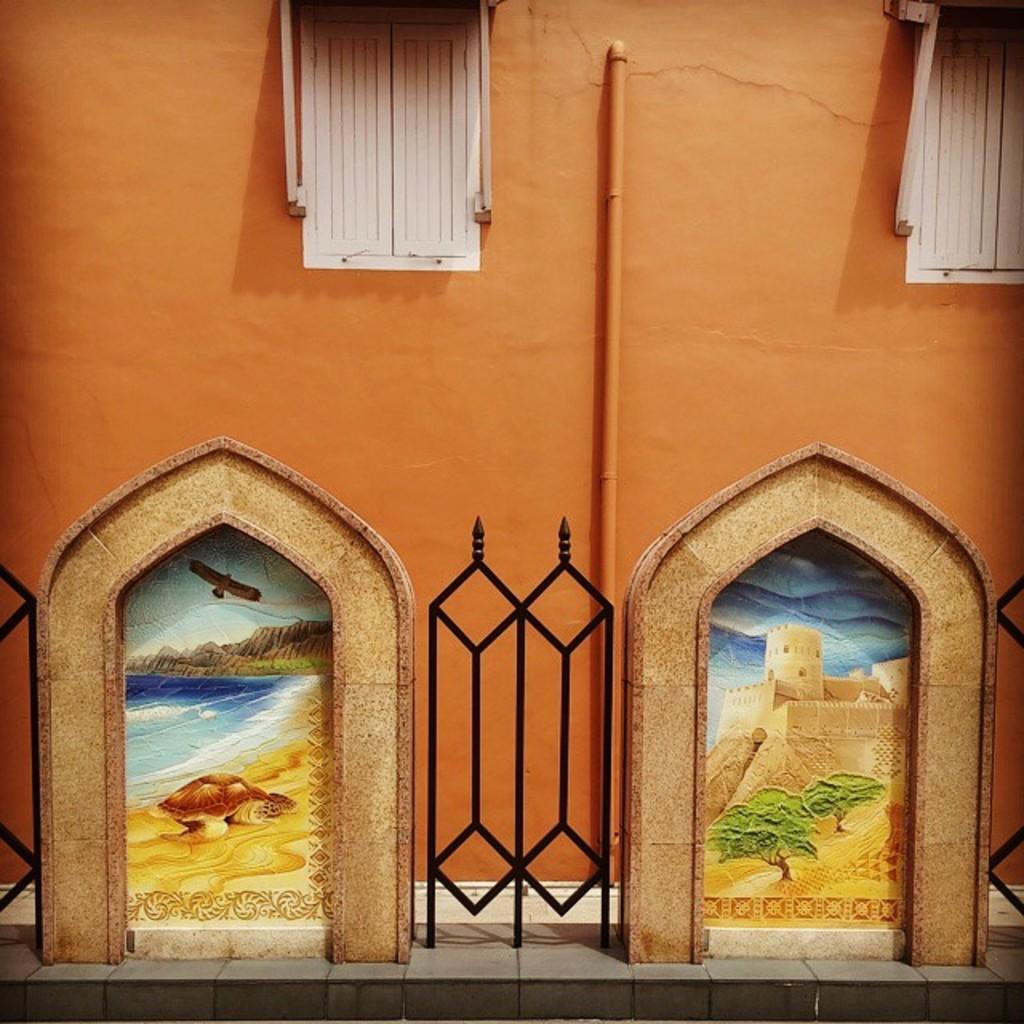Describe this image in one or two sentences. In this image in front there is a railing. There are windows. There is a pipe. There is a painting on the wall. 